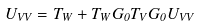<formula> <loc_0><loc_0><loc_500><loc_500>U _ { V V } = T _ { W } + T _ { W } G _ { 0 } T _ { V } G _ { 0 } U _ { V V }</formula> 